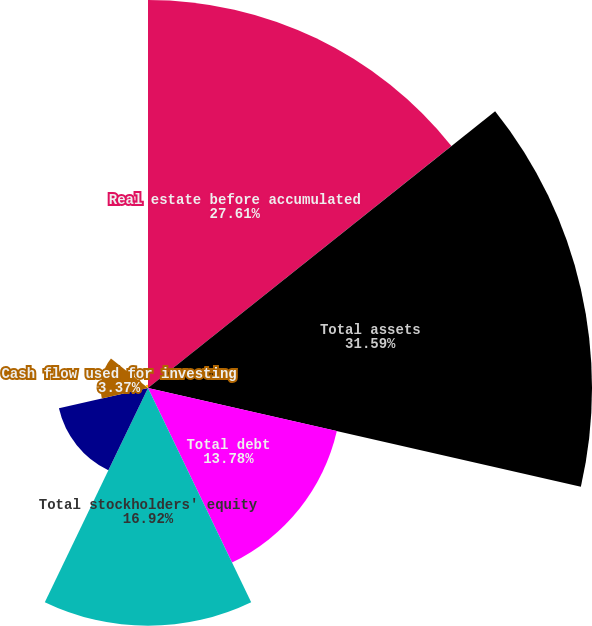<chart> <loc_0><loc_0><loc_500><loc_500><pie_chart><fcel>Real estate before accumulated<fcel>Total assets<fcel>Total debt<fcel>Total stockholders' equity<fcel>Cash flow provided by<fcel>Cash flow used for investing<fcel>Cash flow provided by (used<nl><fcel>27.61%<fcel>31.59%<fcel>13.78%<fcel>16.92%<fcel>6.5%<fcel>3.37%<fcel>0.23%<nl></chart> 